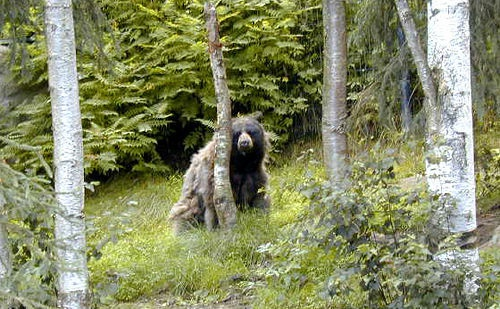Describe the objects in this image and their specific colors. I can see a bear in gray, black, and darkgray tones in this image. 